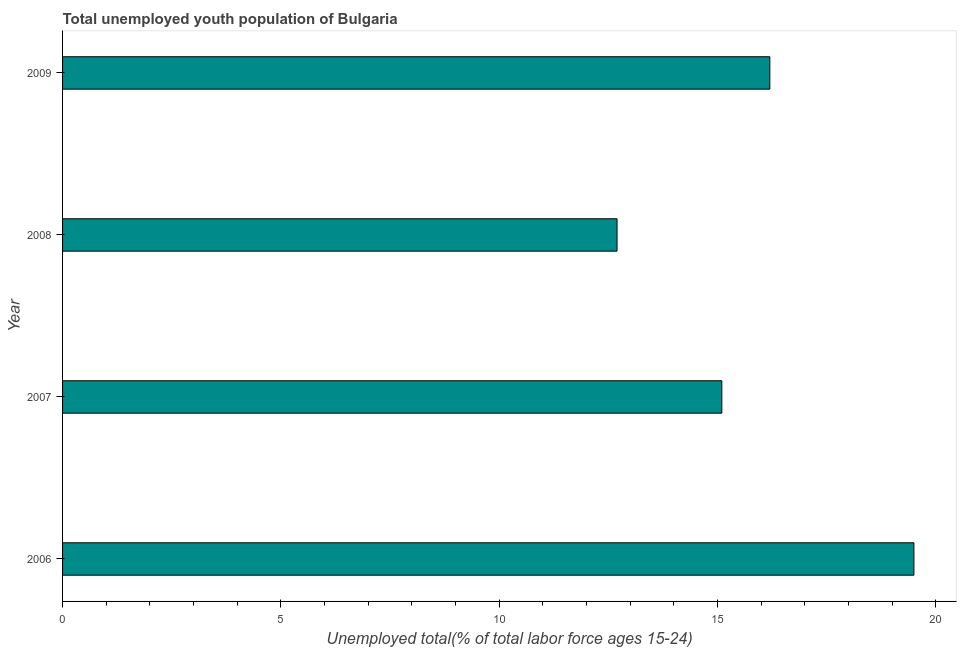Does the graph contain any zero values?
Your answer should be compact. No. Does the graph contain grids?
Provide a short and direct response. No. What is the title of the graph?
Make the answer very short. Total unemployed youth population of Bulgaria. What is the label or title of the X-axis?
Your response must be concise. Unemployed total(% of total labor force ages 15-24). What is the label or title of the Y-axis?
Your answer should be very brief. Year. What is the unemployed youth in 2009?
Ensure brevity in your answer.  16.2. Across all years, what is the minimum unemployed youth?
Your answer should be very brief. 12.7. In which year was the unemployed youth minimum?
Make the answer very short. 2008. What is the sum of the unemployed youth?
Keep it short and to the point. 63.5. What is the average unemployed youth per year?
Keep it short and to the point. 15.88. What is the median unemployed youth?
Provide a short and direct response. 15.65. In how many years, is the unemployed youth greater than 11 %?
Your answer should be compact. 4. Do a majority of the years between 2009 and 2007 (inclusive) have unemployed youth greater than 5 %?
Offer a very short reply. Yes. What is the ratio of the unemployed youth in 2006 to that in 2007?
Give a very brief answer. 1.29. What is the difference between the highest and the second highest unemployed youth?
Your response must be concise. 3.3. How many bars are there?
Keep it short and to the point. 4. How many years are there in the graph?
Your response must be concise. 4. What is the difference between two consecutive major ticks on the X-axis?
Offer a very short reply. 5. What is the Unemployed total(% of total labor force ages 15-24) in 2007?
Your answer should be very brief. 15.1. What is the Unemployed total(% of total labor force ages 15-24) in 2008?
Your response must be concise. 12.7. What is the Unemployed total(% of total labor force ages 15-24) of 2009?
Your answer should be compact. 16.2. What is the difference between the Unemployed total(% of total labor force ages 15-24) in 2006 and 2007?
Offer a terse response. 4.4. What is the difference between the Unemployed total(% of total labor force ages 15-24) in 2006 and 2008?
Provide a short and direct response. 6.8. What is the difference between the Unemployed total(% of total labor force ages 15-24) in 2006 and 2009?
Offer a terse response. 3.3. What is the difference between the Unemployed total(% of total labor force ages 15-24) in 2007 and 2009?
Offer a very short reply. -1.1. What is the ratio of the Unemployed total(% of total labor force ages 15-24) in 2006 to that in 2007?
Provide a succinct answer. 1.29. What is the ratio of the Unemployed total(% of total labor force ages 15-24) in 2006 to that in 2008?
Offer a very short reply. 1.53. What is the ratio of the Unemployed total(% of total labor force ages 15-24) in 2006 to that in 2009?
Offer a terse response. 1.2. What is the ratio of the Unemployed total(% of total labor force ages 15-24) in 2007 to that in 2008?
Your response must be concise. 1.19. What is the ratio of the Unemployed total(% of total labor force ages 15-24) in 2007 to that in 2009?
Offer a very short reply. 0.93. What is the ratio of the Unemployed total(% of total labor force ages 15-24) in 2008 to that in 2009?
Your answer should be compact. 0.78. 